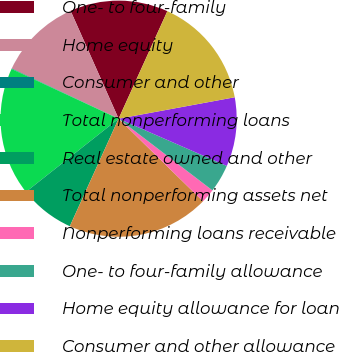<chart> <loc_0><loc_0><loc_500><loc_500><pie_chart><fcel>One- to four-family<fcel>Home equity<fcel>Consumer and other<fcel>Total nonperforming loans<fcel>Real estate owned and other<fcel>Total nonperforming assets net<fcel>Nonperforming loans receivable<fcel>One- to four-family allowance<fcel>Home equity allowance for loan<fcel>Consumer and other allowance<nl><fcel>13.44%<fcel>11.34%<fcel>0.07%<fcel>17.57%<fcel>7.58%<fcel>19.45%<fcel>1.95%<fcel>3.83%<fcel>9.46%<fcel>15.32%<nl></chart> 